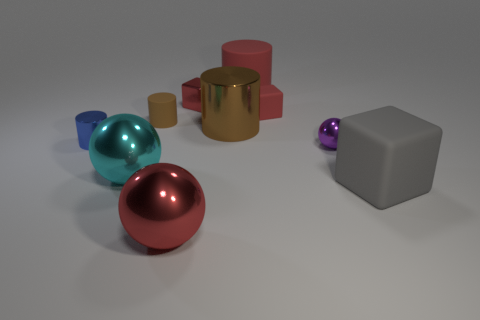Can you describe the lighting in this scene? Where is it coming from? The lighting in the scene seems to be diffuse, likely coming from above as indicated by the soft shadows beneath the objects. There's no harsh direct light or strong reflections, which gives the whole setup a soft and even illumination. 